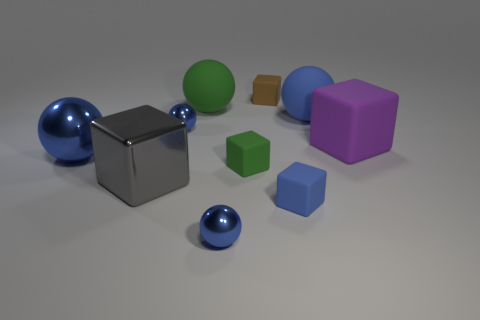How many blue metallic cylinders are there?
Offer a terse response. 0. Is the small blue ball behind the large gray block made of the same material as the green object in front of the big metallic ball?
Give a very brief answer. No. There is another matte object that is the same shape as the big blue rubber object; what color is it?
Your answer should be very brief. Green. What material is the tiny ball behind the large blue thing in front of the large matte block?
Your response must be concise. Metal. Do the big blue thing that is left of the large gray block and the blue matte thing in front of the big gray metal thing have the same shape?
Offer a very short reply. No. What size is the block that is both left of the small blue rubber cube and behind the green matte block?
Your answer should be very brief. Small. How many other things are there of the same color as the big metallic ball?
Provide a succinct answer. 4. Are the big object behind the big blue rubber thing and the gray cube made of the same material?
Give a very brief answer. No. Is there any other thing that has the same size as the green block?
Offer a terse response. Yes. Is the number of balls in front of the purple block less than the number of blue things that are left of the small brown cube?
Ensure brevity in your answer.  Yes. 